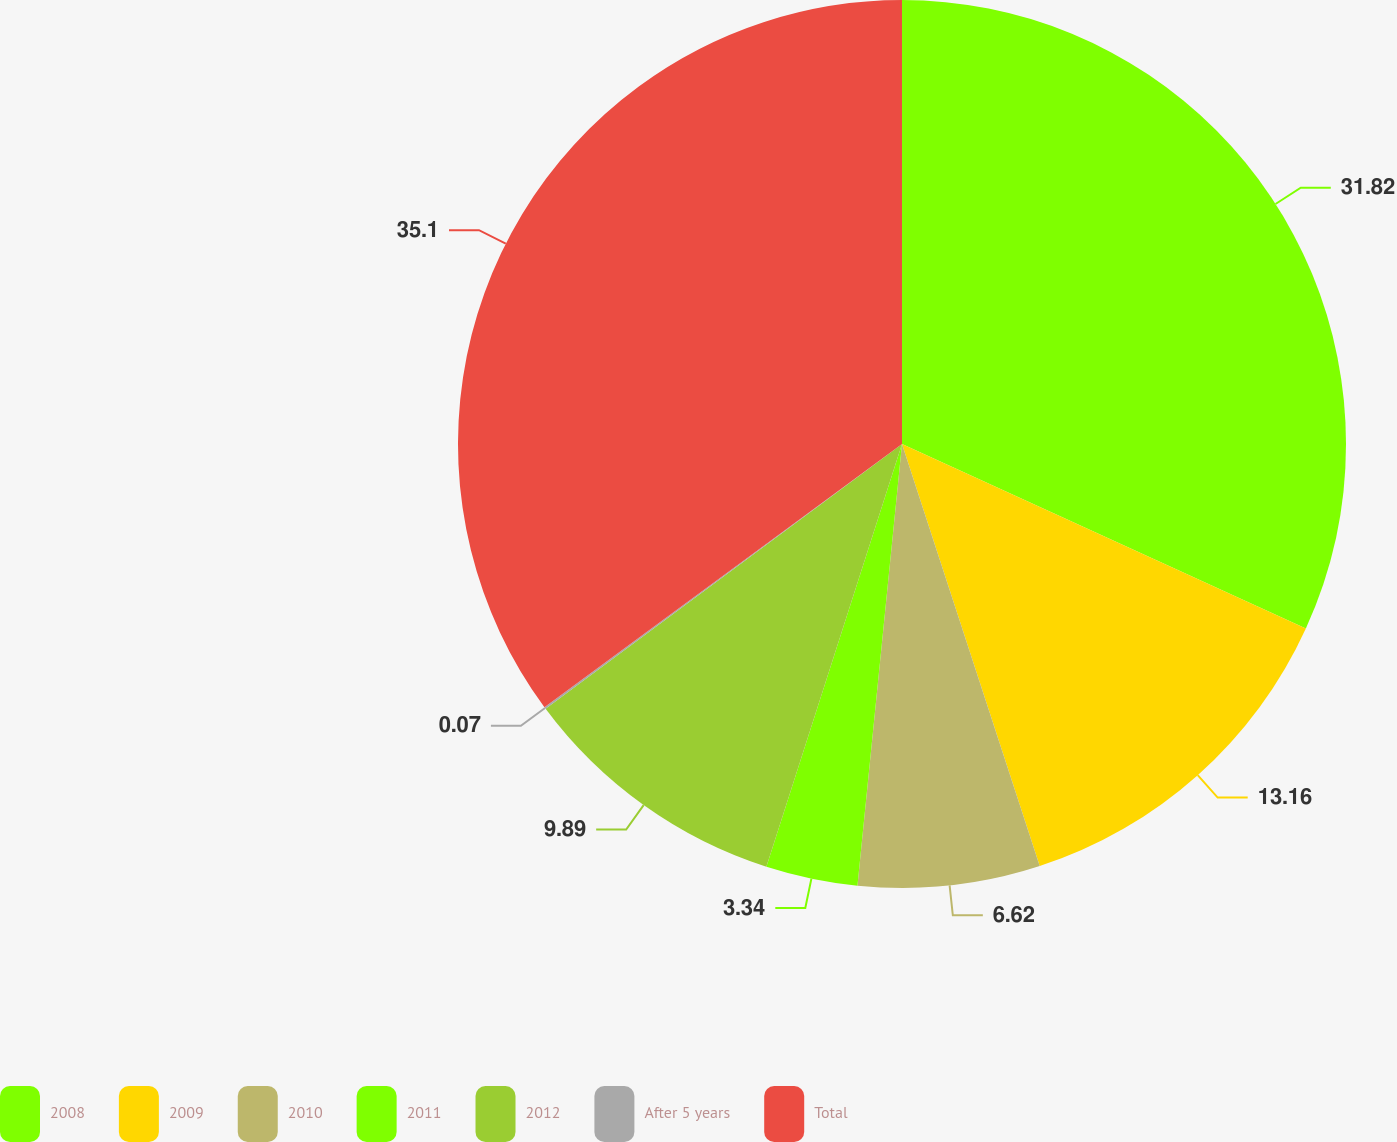Convert chart. <chart><loc_0><loc_0><loc_500><loc_500><pie_chart><fcel>2008<fcel>2009<fcel>2010<fcel>2011<fcel>2012<fcel>After 5 years<fcel>Total<nl><fcel>31.82%<fcel>13.16%<fcel>6.62%<fcel>3.34%<fcel>9.89%<fcel>0.07%<fcel>35.1%<nl></chart> 